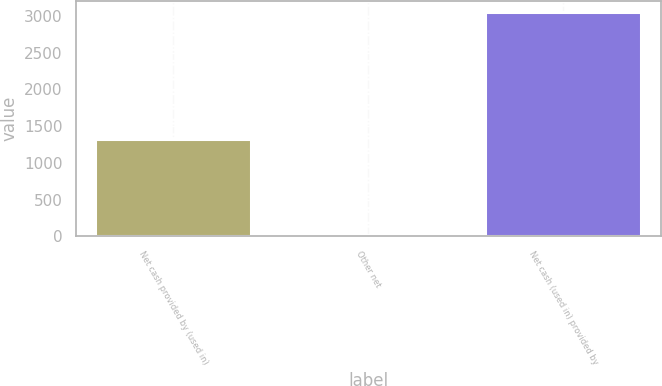Convert chart to OTSL. <chart><loc_0><loc_0><loc_500><loc_500><bar_chart><fcel>Net cash provided by (used in)<fcel>Other net<fcel>Net cash (used in) provided by<nl><fcel>1321<fcel>22<fcel>3055<nl></chart> 